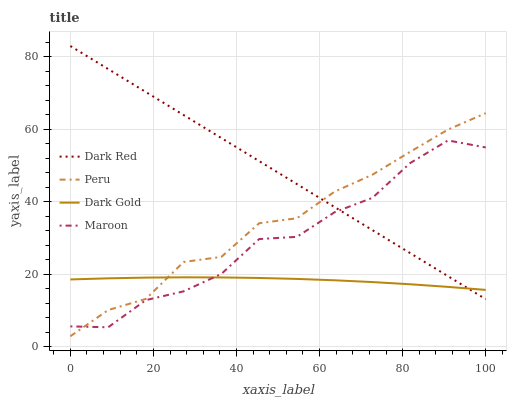Does Maroon have the minimum area under the curve?
Answer yes or no. No. Does Maroon have the maximum area under the curve?
Answer yes or no. No. Is Peru the smoothest?
Answer yes or no. No. Is Peru the roughest?
Answer yes or no. No. Does Maroon have the lowest value?
Answer yes or no. No. Does Maroon have the highest value?
Answer yes or no. No. 